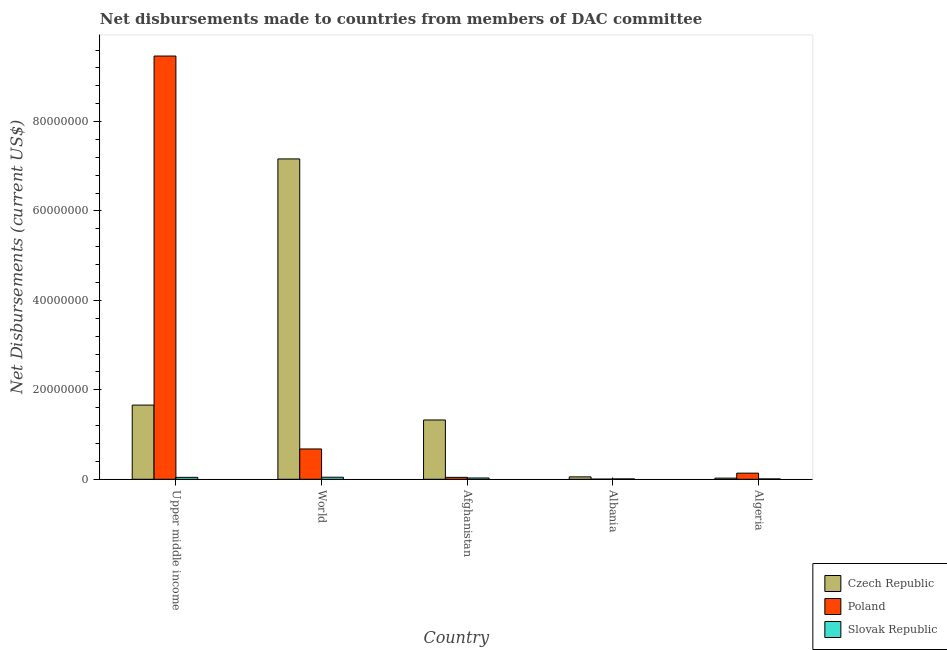How many different coloured bars are there?
Offer a very short reply. 3. Are the number of bars on each tick of the X-axis equal?
Make the answer very short. Yes. How many bars are there on the 3rd tick from the right?
Your response must be concise. 3. What is the label of the 3rd group of bars from the left?
Your answer should be compact. Afghanistan. What is the net disbursements made by poland in Algeria?
Make the answer very short. 1.37e+06. Across all countries, what is the maximum net disbursements made by slovak republic?
Provide a succinct answer. 4.60e+05. Across all countries, what is the minimum net disbursements made by czech republic?
Provide a succinct answer. 2.60e+05. In which country was the net disbursements made by slovak republic maximum?
Your response must be concise. World. In which country was the net disbursements made by slovak republic minimum?
Give a very brief answer. Albania. What is the total net disbursements made by poland in the graph?
Make the answer very short. 1.03e+08. What is the difference between the net disbursements made by poland in Afghanistan and that in Upper middle income?
Your answer should be compact. -9.42e+07. What is the difference between the net disbursements made by poland in Algeria and the net disbursements made by slovak republic in World?
Ensure brevity in your answer.  9.10e+05. What is the average net disbursements made by czech republic per country?
Offer a terse response. 2.05e+07. What is the difference between the net disbursements made by czech republic and net disbursements made by slovak republic in Afghanistan?
Ensure brevity in your answer.  1.30e+07. What is the ratio of the net disbursements made by czech republic in Albania to that in Upper middle income?
Your answer should be compact. 0.03. What is the difference between the highest and the second highest net disbursements made by slovak republic?
Offer a terse response. 3.00e+04. What is the difference between the highest and the lowest net disbursements made by czech republic?
Your answer should be compact. 7.14e+07. What does the 3rd bar from the left in Algeria represents?
Offer a terse response. Slovak Republic. What does the 1st bar from the right in Upper middle income represents?
Provide a succinct answer. Slovak Republic. Is it the case that in every country, the sum of the net disbursements made by czech republic and net disbursements made by poland is greater than the net disbursements made by slovak republic?
Give a very brief answer. Yes. How many bars are there?
Provide a succinct answer. 15. How many countries are there in the graph?
Provide a succinct answer. 5. What is the difference between two consecutive major ticks on the Y-axis?
Offer a terse response. 2.00e+07. Are the values on the major ticks of Y-axis written in scientific E-notation?
Provide a short and direct response. No. Does the graph contain any zero values?
Provide a short and direct response. No. How are the legend labels stacked?
Offer a very short reply. Vertical. What is the title of the graph?
Your answer should be compact. Net disbursements made to countries from members of DAC committee. What is the label or title of the Y-axis?
Your answer should be compact. Net Disbursements (current US$). What is the Net Disbursements (current US$) of Czech Republic in Upper middle income?
Provide a succinct answer. 1.66e+07. What is the Net Disbursements (current US$) in Poland in Upper middle income?
Your answer should be compact. 9.46e+07. What is the Net Disbursements (current US$) of Czech Republic in World?
Offer a terse response. 7.16e+07. What is the Net Disbursements (current US$) of Poland in World?
Offer a terse response. 6.78e+06. What is the Net Disbursements (current US$) of Slovak Republic in World?
Ensure brevity in your answer.  4.60e+05. What is the Net Disbursements (current US$) of Czech Republic in Afghanistan?
Your response must be concise. 1.33e+07. What is the Net Disbursements (current US$) in Poland in Afghanistan?
Your response must be concise. 4.30e+05. What is the Net Disbursements (current US$) in Czech Republic in Albania?
Ensure brevity in your answer.  5.40e+05. What is the Net Disbursements (current US$) in Poland in Albania?
Provide a succinct answer. 3.00e+04. What is the Net Disbursements (current US$) of Czech Republic in Algeria?
Give a very brief answer. 2.60e+05. What is the Net Disbursements (current US$) of Poland in Algeria?
Provide a short and direct response. 1.37e+06. What is the Net Disbursements (current US$) of Slovak Republic in Algeria?
Your answer should be compact. 8.00e+04. Across all countries, what is the maximum Net Disbursements (current US$) in Czech Republic?
Ensure brevity in your answer.  7.16e+07. Across all countries, what is the maximum Net Disbursements (current US$) in Poland?
Make the answer very short. 9.46e+07. Across all countries, what is the maximum Net Disbursements (current US$) in Slovak Republic?
Your response must be concise. 4.60e+05. Across all countries, what is the minimum Net Disbursements (current US$) of Czech Republic?
Provide a short and direct response. 2.60e+05. Across all countries, what is the minimum Net Disbursements (current US$) of Slovak Republic?
Your answer should be very brief. 8.00e+04. What is the total Net Disbursements (current US$) in Czech Republic in the graph?
Make the answer very short. 1.02e+08. What is the total Net Disbursements (current US$) of Poland in the graph?
Make the answer very short. 1.03e+08. What is the total Net Disbursements (current US$) in Slovak Republic in the graph?
Provide a short and direct response. 1.34e+06. What is the difference between the Net Disbursements (current US$) in Czech Republic in Upper middle income and that in World?
Offer a terse response. -5.50e+07. What is the difference between the Net Disbursements (current US$) of Poland in Upper middle income and that in World?
Provide a short and direct response. 8.79e+07. What is the difference between the Net Disbursements (current US$) of Slovak Republic in Upper middle income and that in World?
Your response must be concise. -3.00e+04. What is the difference between the Net Disbursements (current US$) in Czech Republic in Upper middle income and that in Afghanistan?
Keep it short and to the point. 3.33e+06. What is the difference between the Net Disbursements (current US$) in Poland in Upper middle income and that in Afghanistan?
Keep it short and to the point. 9.42e+07. What is the difference between the Net Disbursements (current US$) of Czech Republic in Upper middle income and that in Albania?
Your answer should be compact. 1.60e+07. What is the difference between the Net Disbursements (current US$) in Poland in Upper middle income and that in Albania?
Your response must be concise. 9.46e+07. What is the difference between the Net Disbursements (current US$) of Slovak Republic in Upper middle income and that in Albania?
Provide a succinct answer. 3.50e+05. What is the difference between the Net Disbursements (current US$) of Czech Republic in Upper middle income and that in Algeria?
Provide a short and direct response. 1.63e+07. What is the difference between the Net Disbursements (current US$) of Poland in Upper middle income and that in Algeria?
Offer a terse response. 9.33e+07. What is the difference between the Net Disbursements (current US$) of Slovak Republic in Upper middle income and that in Algeria?
Provide a short and direct response. 3.50e+05. What is the difference between the Net Disbursements (current US$) in Czech Republic in World and that in Afghanistan?
Provide a succinct answer. 5.84e+07. What is the difference between the Net Disbursements (current US$) in Poland in World and that in Afghanistan?
Provide a short and direct response. 6.35e+06. What is the difference between the Net Disbursements (current US$) of Slovak Republic in World and that in Afghanistan?
Your response must be concise. 1.70e+05. What is the difference between the Net Disbursements (current US$) in Czech Republic in World and that in Albania?
Offer a very short reply. 7.11e+07. What is the difference between the Net Disbursements (current US$) in Poland in World and that in Albania?
Ensure brevity in your answer.  6.75e+06. What is the difference between the Net Disbursements (current US$) of Slovak Republic in World and that in Albania?
Provide a succinct answer. 3.80e+05. What is the difference between the Net Disbursements (current US$) in Czech Republic in World and that in Algeria?
Offer a very short reply. 7.14e+07. What is the difference between the Net Disbursements (current US$) of Poland in World and that in Algeria?
Keep it short and to the point. 5.41e+06. What is the difference between the Net Disbursements (current US$) in Slovak Republic in World and that in Algeria?
Offer a terse response. 3.80e+05. What is the difference between the Net Disbursements (current US$) of Czech Republic in Afghanistan and that in Albania?
Keep it short and to the point. 1.27e+07. What is the difference between the Net Disbursements (current US$) of Slovak Republic in Afghanistan and that in Albania?
Offer a terse response. 2.10e+05. What is the difference between the Net Disbursements (current US$) of Czech Republic in Afghanistan and that in Algeria?
Your answer should be very brief. 1.30e+07. What is the difference between the Net Disbursements (current US$) in Poland in Afghanistan and that in Algeria?
Keep it short and to the point. -9.40e+05. What is the difference between the Net Disbursements (current US$) of Slovak Republic in Afghanistan and that in Algeria?
Provide a succinct answer. 2.10e+05. What is the difference between the Net Disbursements (current US$) in Czech Republic in Albania and that in Algeria?
Your answer should be very brief. 2.80e+05. What is the difference between the Net Disbursements (current US$) of Poland in Albania and that in Algeria?
Keep it short and to the point. -1.34e+06. What is the difference between the Net Disbursements (current US$) in Czech Republic in Upper middle income and the Net Disbursements (current US$) in Poland in World?
Provide a succinct answer. 9.81e+06. What is the difference between the Net Disbursements (current US$) of Czech Republic in Upper middle income and the Net Disbursements (current US$) of Slovak Republic in World?
Offer a very short reply. 1.61e+07. What is the difference between the Net Disbursements (current US$) of Poland in Upper middle income and the Net Disbursements (current US$) of Slovak Republic in World?
Give a very brief answer. 9.42e+07. What is the difference between the Net Disbursements (current US$) in Czech Republic in Upper middle income and the Net Disbursements (current US$) in Poland in Afghanistan?
Provide a succinct answer. 1.62e+07. What is the difference between the Net Disbursements (current US$) of Czech Republic in Upper middle income and the Net Disbursements (current US$) of Slovak Republic in Afghanistan?
Give a very brief answer. 1.63e+07. What is the difference between the Net Disbursements (current US$) in Poland in Upper middle income and the Net Disbursements (current US$) in Slovak Republic in Afghanistan?
Make the answer very short. 9.44e+07. What is the difference between the Net Disbursements (current US$) in Czech Republic in Upper middle income and the Net Disbursements (current US$) in Poland in Albania?
Give a very brief answer. 1.66e+07. What is the difference between the Net Disbursements (current US$) in Czech Republic in Upper middle income and the Net Disbursements (current US$) in Slovak Republic in Albania?
Offer a terse response. 1.65e+07. What is the difference between the Net Disbursements (current US$) of Poland in Upper middle income and the Net Disbursements (current US$) of Slovak Republic in Albania?
Your response must be concise. 9.46e+07. What is the difference between the Net Disbursements (current US$) of Czech Republic in Upper middle income and the Net Disbursements (current US$) of Poland in Algeria?
Give a very brief answer. 1.52e+07. What is the difference between the Net Disbursements (current US$) of Czech Republic in Upper middle income and the Net Disbursements (current US$) of Slovak Republic in Algeria?
Offer a terse response. 1.65e+07. What is the difference between the Net Disbursements (current US$) in Poland in Upper middle income and the Net Disbursements (current US$) in Slovak Republic in Algeria?
Ensure brevity in your answer.  9.46e+07. What is the difference between the Net Disbursements (current US$) of Czech Republic in World and the Net Disbursements (current US$) of Poland in Afghanistan?
Offer a terse response. 7.12e+07. What is the difference between the Net Disbursements (current US$) in Czech Republic in World and the Net Disbursements (current US$) in Slovak Republic in Afghanistan?
Offer a very short reply. 7.14e+07. What is the difference between the Net Disbursements (current US$) in Poland in World and the Net Disbursements (current US$) in Slovak Republic in Afghanistan?
Offer a terse response. 6.49e+06. What is the difference between the Net Disbursements (current US$) in Czech Republic in World and the Net Disbursements (current US$) in Poland in Albania?
Your answer should be compact. 7.16e+07. What is the difference between the Net Disbursements (current US$) in Czech Republic in World and the Net Disbursements (current US$) in Slovak Republic in Albania?
Offer a very short reply. 7.16e+07. What is the difference between the Net Disbursements (current US$) of Poland in World and the Net Disbursements (current US$) of Slovak Republic in Albania?
Ensure brevity in your answer.  6.70e+06. What is the difference between the Net Disbursements (current US$) in Czech Republic in World and the Net Disbursements (current US$) in Poland in Algeria?
Your response must be concise. 7.03e+07. What is the difference between the Net Disbursements (current US$) of Czech Republic in World and the Net Disbursements (current US$) of Slovak Republic in Algeria?
Offer a terse response. 7.16e+07. What is the difference between the Net Disbursements (current US$) of Poland in World and the Net Disbursements (current US$) of Slovak Republic in Algeria?
Ensure brevity in your answer.  6.70e+06. What is the difference between the Net Disbursements (current US$) of Czech Republic in Afghanistan and the Net Disbursements (current US$) of Poland in Albania?
Your answer should be very brief. 1.32e+07. What is the difference between the Net Disbursements (current US$) in Czech Republic in Afghanistan and the Net Disbursements (current US$) in Slovak Republic in Albania?
Your response must be concise. 1.32e+07. What is the difference between the Net Disbursements (current US$) of Czech Republic in Afghanistan and the Net Disbursements (current US$) of Poland in Algeria?
Your response must be concise. 1.19e+07. What is the difference between the Net Disbursements (current US$) of Czech Republic in Afghanistan and the Net Disbursements (current US$) of Slovak Republic in Algeria?
Offer a terse response. 1.32e+07. What is the difference between the Net Disbursements (current US$) in Czech Republic in Albania and the Net Disbursements (current US$) in Poland in Algeria?
Your response must be concise. -8.30e+05. What is the difference between the Net Disbursements (current US$) of Czech Republic in Albania and the Net Disbursements (current US$) of Slovak Republic in Algeria?
Your answer should be very brief. 4.60e+05. What is the average Net Disbursements (current US$) of Czech Republic per country?
Give a very brief answer. 2.05e+07. What is the average Net Disbursements (current US$) of Poland per country?
Offer a very short reply. 2.07e+07. What is the average Net Disbursements (current US$) of Slovak Republic per country?
Make the answer very short. 2.68e+05. What is the difference between the Net Disbursements (current US$) in Czech Republic and Net Disbursements (current US$) in Poland in Upper middle income?
Keep it short and to the point. -7.81e+07. What is the difference between the Net Disbursements (current US$) of Czech Republic and Net Disbursements (current US$) of Slovak Republic in Upper middle income?
Ensure brevity in your answer.  1.62e+07. What is the difference between the Net Disbursements (current US$) of Poland and Net Disbursements (current US$) of Slovak Republic in Upper middle income?
Provide a short and direct response. 9.42e+07. What is the difference between the Net Disbursements (current US$) of Czech Republic and Net Disbursements (current US$) of Poland in World?
Keep it short and to the point. 6.49e+07. What is the difference between the Net Disbursements (current US$) in Czech Republic and Net Disbursements (current US$) in Slovak Republic in World?
Offer a very short reply. 7.12e+07. What is the difference between the Net Disbursements (current US$) of Poland and Net Disbursements (current US$) of Slovak Republic in World?
Provide a short and direct response. 6.32e+06. What is the difference between the Net Disbursements (current US$) of Czech Republic and Net Disbursements (current US$) of Poland in Afghanistan?
Your answer should be compact. 1.28e+07. What is the difference between the Net Disbursements (current US$) of Czech Republic and Net Disbursements (current US$) of Slovak Republic in Afghanistan?
Make the answer very short. 1.30e+07. What is the difference between the Net Disbursements (current US$) in Poland and Net Disbursements (current US$) in Slovak Republic in Afghanistan?
Your answer should be compact. 1.40e+05. What is the difference between the Net Disbursements (current US$) of Czech Republic and Net Disbursements (current US$) of Poland in Albania?
Provide a short and direct response. 5.10e+05. What is the difference between the Net Disbursements (current US$) in Czech Republic and Net Disbursements (current US$) in Slovak Republic in Albania?
Your response must be concise. 4.60e+05. What is the difference between the Net Disbursements (current US$) of Poland and Net Disbursements (current US$) of Slovak Republic in Albania?
Your answer should be very brief. -5.00e+04. What is the difference between the Net Disbursements (current US$) of Czech Republic and Net Disbursements (current US$) of Poland in Algeria?
Your answer should be very brief. -1.11e+06. What is the difference between the Net Disbursements (current US$) of Czech Republic and Net Disbursements (current US$) of Slovak Republic in Algeria?
Offer a very short reply. 1.80e+05. What is the difference between the Net Disbursements (current US$) in Poland and Net Disbursements (current US$) in Slovak Republic in Algeria?
Give a very brief answer. 1.29e+06. What is the ratio of the Net Disbursements (current US$) in Czech Republic in Upper middle income to that in World?
Your answer should be compact. 0.23. What is the ratio of the Net Disbursements (current US$) of Poland in Upper middle income to that in World?
Your answer should be very brief. 13.96. What is the ratio of the Net Disbursements (current US$) in Slovak Republic in Upper middle income to that in World?
Provide a succinct answer. 0.93. What is the ratio of the Net Disbursements (current US$) of Czech Republic in Upper middle income to that in Afghanistan?
Make the answer very short. 1.25. What is the ratio of the Net Disbursements (current US$) of Poland in Upper middle income to that in Afghanistan?
Offer a terse response. 220.12. What is the ratio of the Net Disbursements (current US$) of Slovak Republic in Upper middle income to that in Afghanistan?
Offer a very short reply. 1.48. What is the ratio of the Net Disbursements (current US$) of Czech Republic in Upper middle income to that in Albania?
Your answer should be very brief. 30.72. What is the ratio of the Net Disbursements (current US$) of Poland in Upper middle income to that in Albania?
Ensure brevity in your answer.  3155. What is the ratio of the Net Disbursements (current US$) in Slovak Republic in Upper middle income to that in Albania?
Make the answer very short. 5.38. What is the ratio of the Net Disbursements (current US$) in Czech Republic in Upper middle income to that in Algeria?
Ensure brevity in your answer.  63.81. What is the ratio of the Net Disbursements (current US$) in Poland in Upper middle income to that in Algeria?
Offer a terse response. 69.09. What is the ratio of the Net Disbursements (current US$) of Slovak Republic in Upper middle income to that in Algeria?
Your answer should be compact. 5.38. What is the ratio of the Net Disbursements (current US$) in Czech Republic in World to that in Afghanistan?
Your answer should be compact. 5.4. What is the ratio of the Net Disbursements (current US$) in Poland in World to that in Afghanistan?
Your response must be concise. 15.77. What is the ratio of the Net Disbursements (current US$) in Slovak Republic in World to that in Afghanistan?
Make the answer very short. 1.59. What is the ratio of the Net Disbursements (current US$) of Czech Republic in World to that in Albania?
Ensure brevity in your answer.  132.67. What is the ratio of the Net Disbursements (current US$) in Poland in World to that in Albania?
Your response must be concise. 226. What is the ratio of the Net Disbursements (current US$) in Slovak Republic in World to that in Albania?
Ensure brevity in your answer.  5.75. What is the ratio of the Net Disbursements (current US$) in Czech Republic in World to that in Algeria?
Your response must be concise. 275.54. What is the ratio of the Net Disbursements (current US$) of Poland in World to that in Algeria?
Ensure brevity in your answer.  4.95. What is the ratio of the Net Disbursements (current US$) of Slovak Republic in World to that in Algeria?
Offer a very short reply. 5.75. What is the ratio of the Net Disbursements (current US$) in Czech Republic in Afghanistan to that in Albania?
Ensure brevity in your answer.  24.56. What is the ratio of the Net Disbursements (current US$) of Poland in Afghanistan to that in Albania?
Provide a succinct answer. 14.33. What is the ratio of the Net Disbursements (current US$) in Slovak Republic in Afghanistan to that in Albania?
Your answer should be very brief. 3.62. What is the ratio of the Net Disbursements (current US$) in Czech Republic in Afghanistan to that in Algeria?
Ensure brevity in your answer.  51. What is the ratio of the Net Disbursements (current US$) of Poland in Afghanistan to that in Algeria?
Give a very brief answer. 0.31. What is the ratio of the Net Disbursements (current US$) of Slovak Republic in Afghanistan to that in Algeria?
Your answer should be very brief. 3.62. What is the ratio of the Net Disbursements (current US$) in Czech Republic in Albania to that in Algeria?
Offer a terse response. 2.08. What is the ratio of the Net Disbursements (current US$) in Poland in Albania to that in Algeria?
Your response must be concise. 0.02. What is the ratio of the Net Disbursements (current US$) of Slovak Republic in Albania to that in Algeria?
Offer a very short reply. 1. What is the difference between the highest and the second highest Net Disbursements (current US$) in Czech Republic?
Offer a terse response. 5.50e+07. What is the difference between the highest and the second highest Net Disbursements (current US$) of Poland?
Offer a terse response. 8.79e+07. What is the difference between the highest and the second highest Net Disbursements (current US$) in Slovak Republic?
Your answer should be compact. 3.00e+04. What is the difference between the highest and the lowest Net Disbursements (current US$) of Czech Republic?
Your response must be concise. 7.14e+07. What is the difference between the highest and the lowest Net Disbursements (current US$) in Poland?
Offer a terse response. 9.46e+07. What is the difference between the highest and the lowest Net Disbursements (current US$) of Slovak Republic?
Provide a short and direct response. 3.80e+05. 